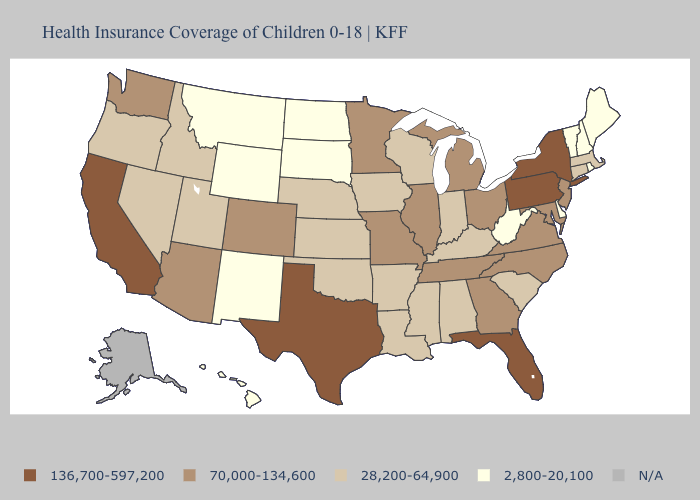Name the states that have a value in the range 28,200-64,900?
Write a very short answer. Alabama, Arkansas, Connecticut, Idaho, Indiana, Iowa, Kansas, Kentucky, Louisiana, Massachusetts, Mississippi, Nebraska, Nevada, Oklahoma, Oregon, South Carolina, Utah, Wisconsin. Does the map have missing data?
Write a very short answer. Yes. What is the value of West Virginia?
Be succinct. 2,800-20,100. Does West Virginia have the lowest value in the USA?
Answer briefly. Yes. What is the highest value in states that border Wisconsin?
Keep it brief. 70,000-134,600. How many symbols are there in the legend?
Concise answer only. 5. What is the highest value in states that border California?
Be succinct. 70,000-134,600. Is the legend a continuous bar?
Answer briefly. No. Does the first symbol in the legend represent the smallest category?
Concise answer only. No. What is the lowest value in states that border Missouri?
Concise answer only. 28,200-64,900. Name the states that have a value in the range 2,800-20,100?
Keep it brief. Delaware, Hawaii, Maine, Montana, New Hampshire, New Mexico, North Dakota, Rhode Island, South Dakota, Vermont, West Virginia, Wyoming. Name the states that have a value in the range N/A?
Quick response, please. Alaska. 